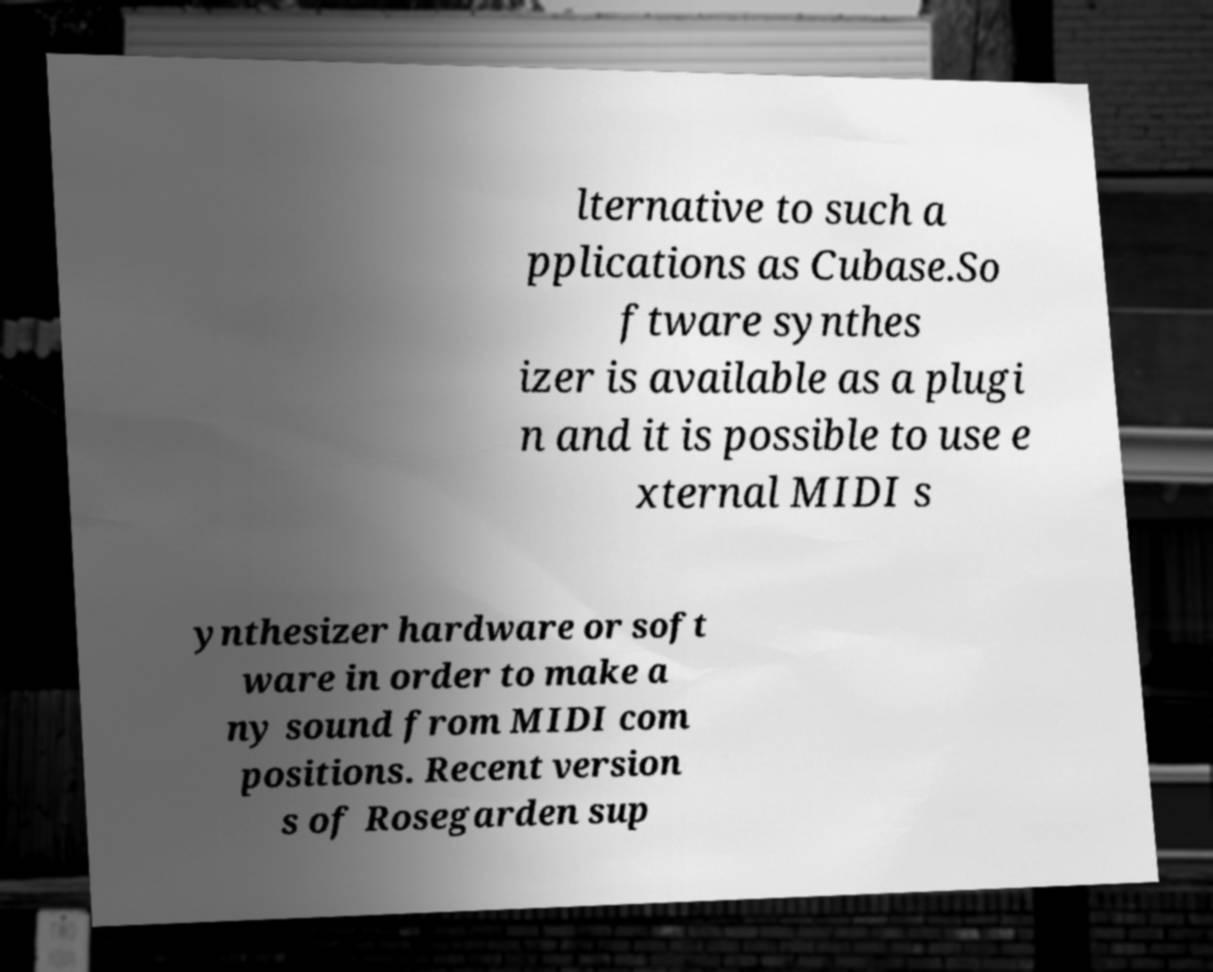Please read and relay the text visible in this image. What does it say? lternative to such a pplications as Cubase.So ftware synthes izer is available as a plugi n and it is possible to use e xternal MIDI s ynthesizer hardware or soft ware in order to make a ny sound from MIDI com positions. Recent version s of Rosegarden sup 